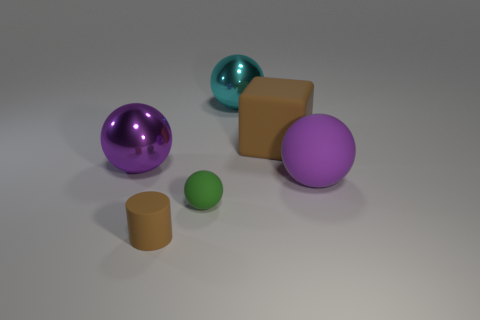There is a brown matte object behind the purple sphere that is right of the block; what is its size?
Offer a terse response. Large. There is a brown matte thing in front of the big purple sphere to the right of the big thing on the left side of the tiny green rubber thing; what shape is it?
Provide a succinct answer. Cylinder. What size is the other brown object that is the same material as the small brown object?
Your response must be concise. Large. Is the number of large matte balls greater than the number of tiny gray blocks?
Your answer should be compact. Yes. What is the material of the brown cube that is the same size as the cyan metallic sphere?
Provide a succinct answer. Rubber. There is a purple ball that is left of the cyan ball; does it have the same size as the brown rubber cylinder?
Your answer should be compact. No. How many spheres are small brown objects or small green matte things?
Your response must be concise. 1. What is the purple ball behind the purple matte ball made of?
Keep it short and to the point. Metal. Is the number of big green metallic cylinders less than the number of large cyan metallic objects?
Offer a very short reply. Yes. There is a matte thing that is right of the cyan metal object and in front of the large brown thing; what size is it?
Offer a terse response. Large. 